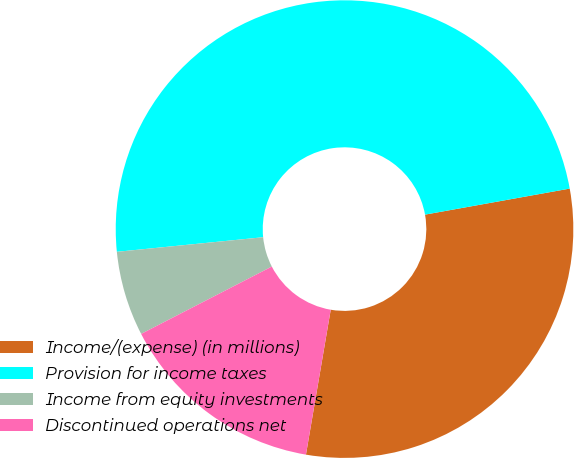Convert chart. <chart><loc_0><loc_0><loc_500><loc_500><pie_chart><fcel>Income/(expense) (in millions)<fcel>Provision for income taxes<fcel>Income from equity investments<fcel>Discontinued operations net<nl><fcel>30.53%<fcel>48.75%<fcel>5.99%<fcel>14.73%<nl></chart> 